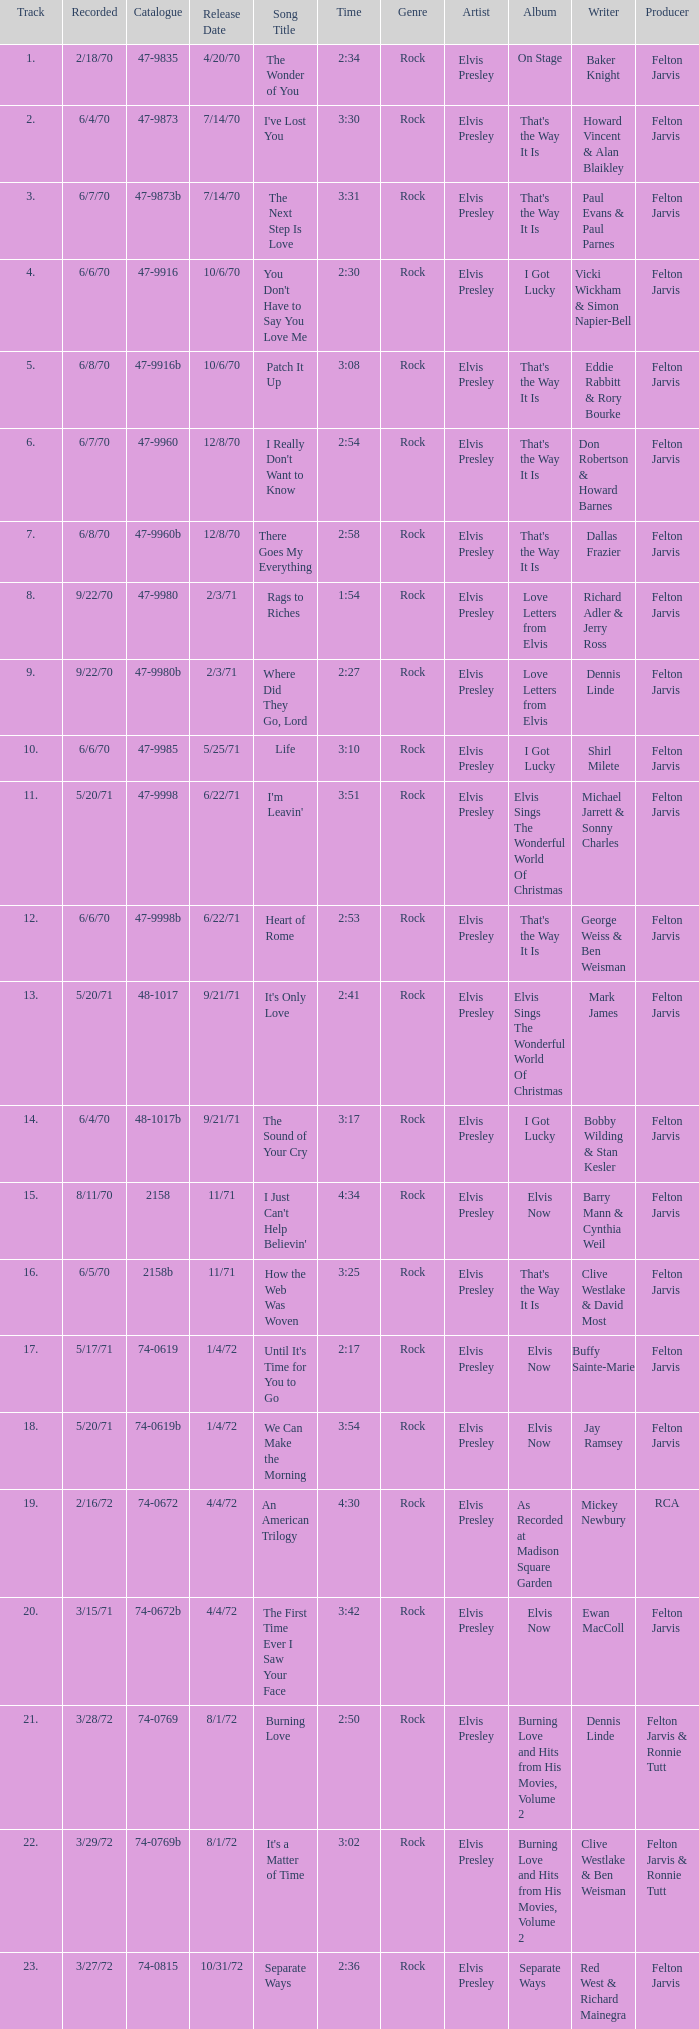What is Heart of Rome's catalogue number? 47-9998b. 